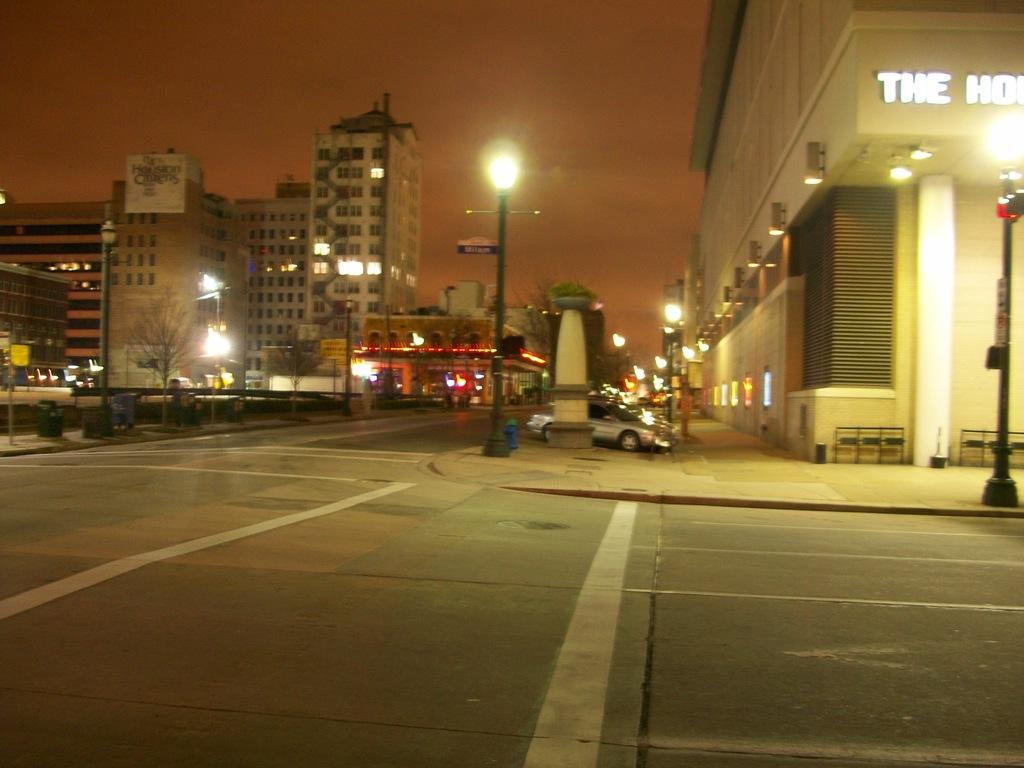What type of structures can be seen in the image? There are buildings in the image. What type of lighting is present in the image? There are street lamps in the image. What type of vehicles are visible in the image? There are cars in the image. What type of plant is present in the image? There is a tree in the image. What part of the natural environment is visible in the image? The sky is visible in the image. How would you describe the lighting conditions in the image? The image appears to be slightly dark. Where is the bee buzzing around the playground in the image? There is no bee or playground present in the image. What type of whip is being used by the person in the image? There is no person or whip present in the image. 